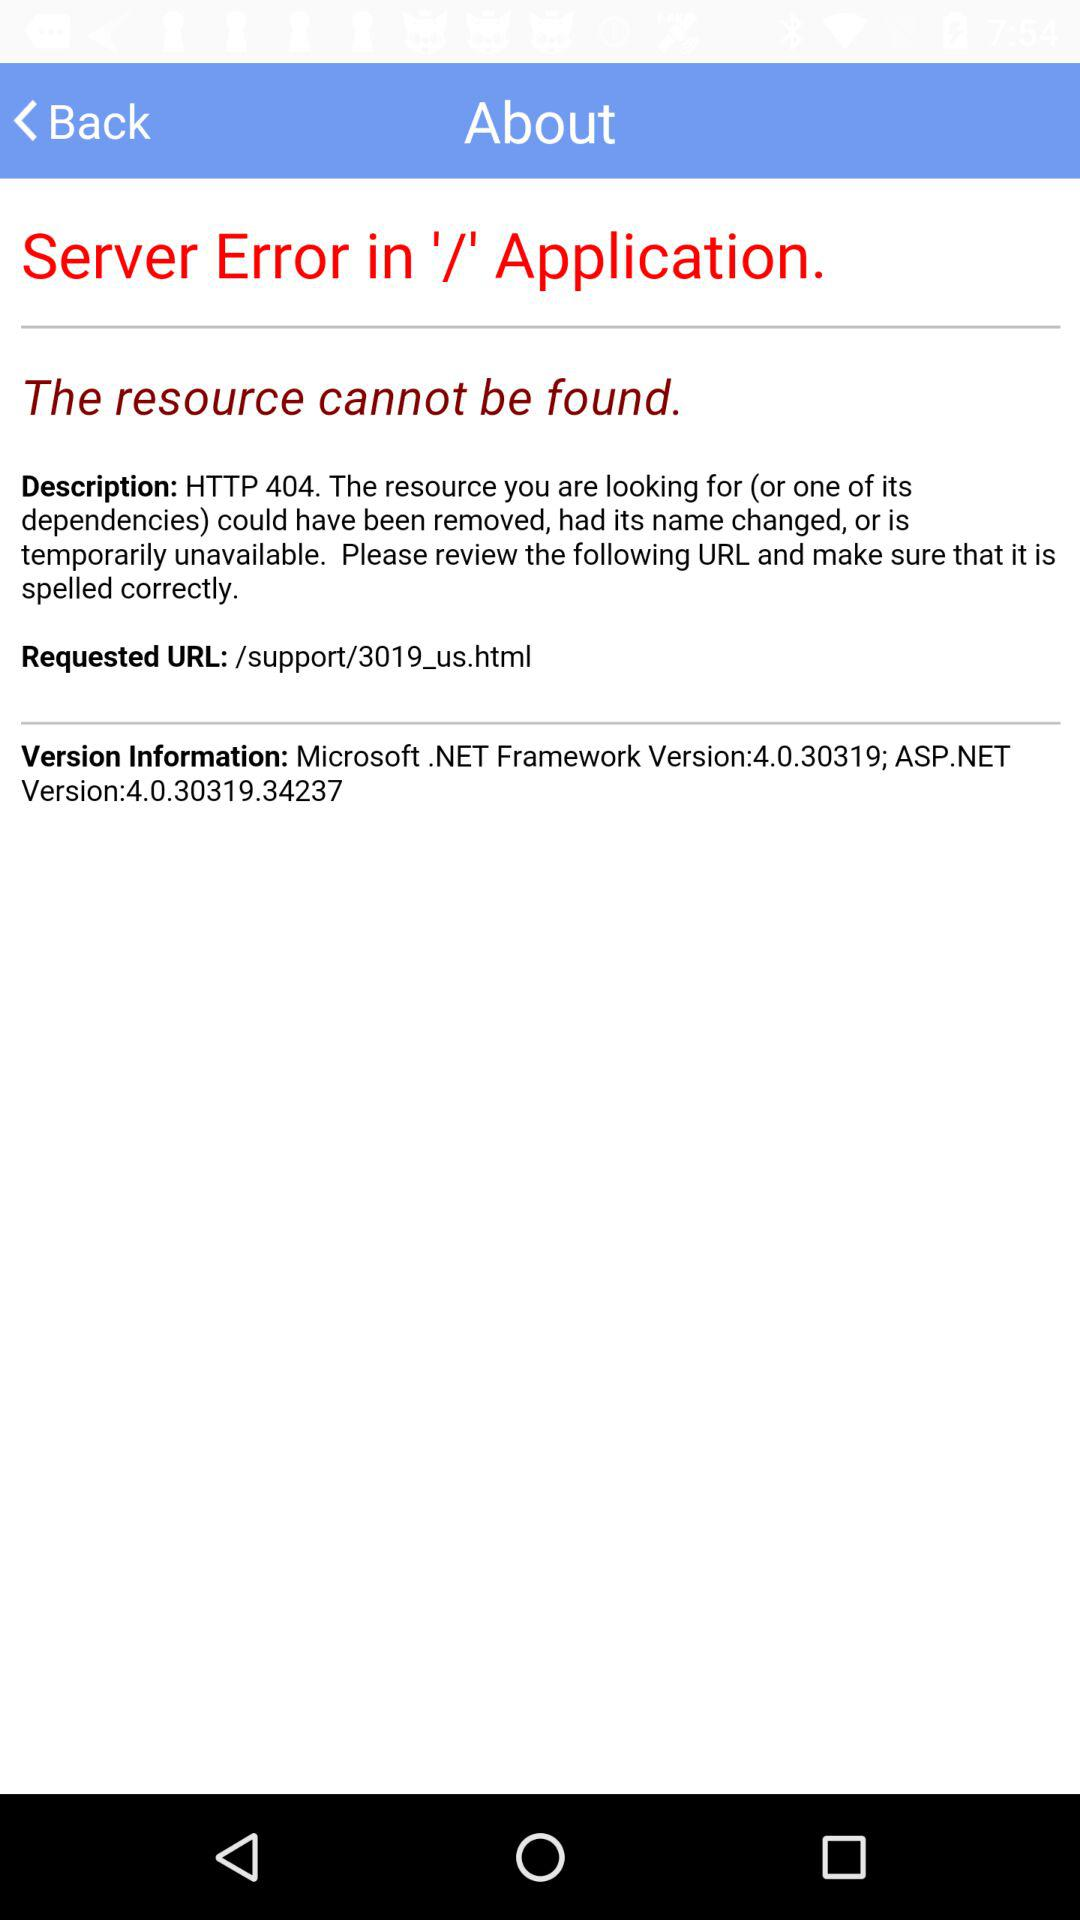What is the requested URL? The URL is /support/3019_us.html. 